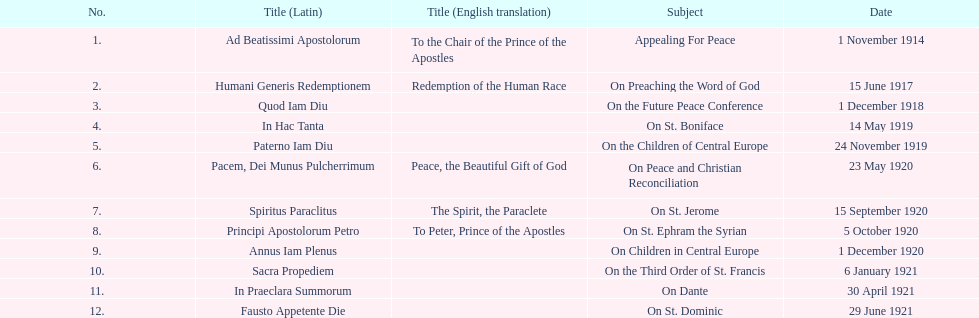What is the total number of encyclicals to take place in december? 2. Give me the full table as a dictionary. {'header': ['No.', 'Title (Latin)', 'Title (English translation)', 'Subject', 'Date'], 'rows': [['1.', 'Ad Beatissimi Apostolorum', 'To the Chair of the Prince of the Apostles', 'Appealing For Peace', '1 November 1914'], ['2.', 'Humani Generis Redemptionem', 'Redemption of the Human Race', 'On Preaching the Word of God', '15 June 1917'], ['3.', 'Quod Iam Diu', '', 'On the Future Peace Conference', '1 December 1918'], ['4.', 'In Hac Tanta', '', 'On St. Boniface', '14 May 1919'], ['5.', 'Paterno Iam Diu', '', 'On the Children of Central Europe', '24 November 1919'], ['6.', 'Pacem, Dei Munus Pulcherrimum', 'Peace, the Beautiful Gift of God', 'On Peace and Christian Reconciliation', '23 May 1920'], ['7.', 'Spiritus Paraclitus', 'The Spirit, the Paraclete', 'On St. Jerome', '15 September 1920'], ['8.', 'Principi Apostolorum Petro', 'To Peter, Prince of the Apostles', 'On St. Ephram the Syrian', '5 October 1920'], ['9.', 'Annus Iam Plenus', '', 'On Children in Central Europe', '1 December 1920'], ['10.', 'Sacra Propediem', '', 'On the Third Order of St. Francis', '6 January 1921'], ['11.', 'In Praeclara Summorum', '', 'On Dante', '30 April 1921'], ['12.', 'Fausto Appetente Die', '', 'On St. Dominic', '29 June 1921']]} 